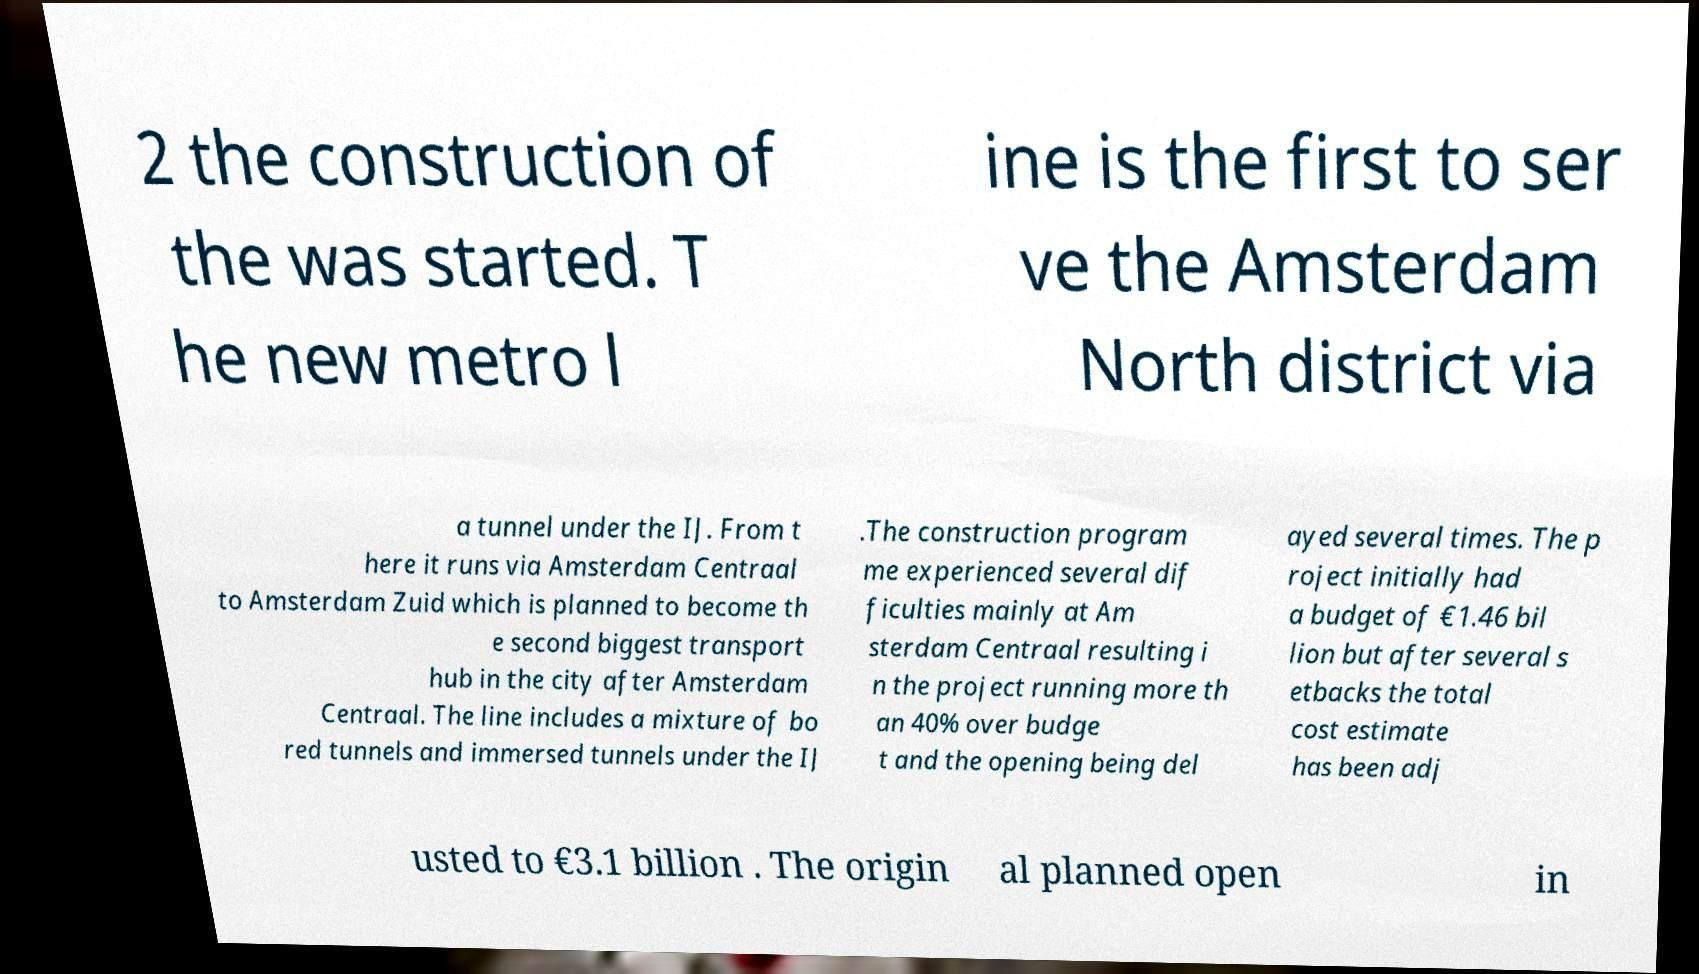Could you extract and type out the text from this image? 2 the construction of the was started. T he new metro l ine is the first to ser ve the Amsterdam North district via a tunnel under the IJ. From t here it runs via Amsterdam Centraal to Amsterdam Zuid which is planned to become th e second biggest transport hub in the city after Amsterdam Centraal. The line includes a mixture of bo red tunnels and immersed tunnels under the IJ .The construction program me experienced several dif ficulties mainly at Am sterdam Centraal resulting i n the project running more th an 40% over budge t and the opening being del ayed several times. The p roject initially had a budget of €1.46 bil lion but after several s etbacks the total cost estimate has been adj usted to €3.1 billion . The origin al planned open in 